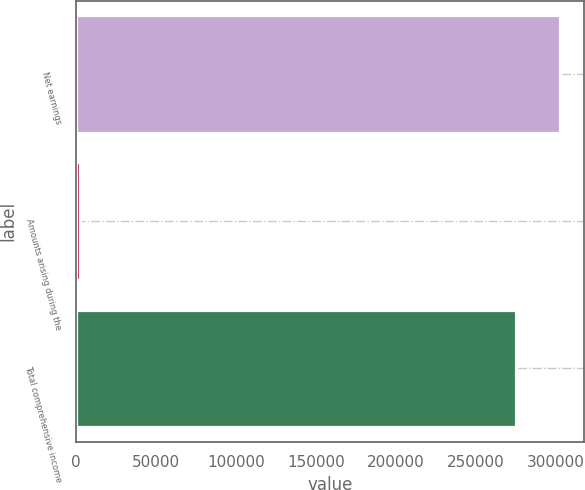Convert chart to OTSL. <chart><loc_0><loc_0><loc_500><loc_500><bar_chart><fcel>Net earnings<fcel>Amounts arising during the<fcel>Total comprehensive income<nl><fcel>302674<fcel>2686<fcel>275158<nl></chart> 